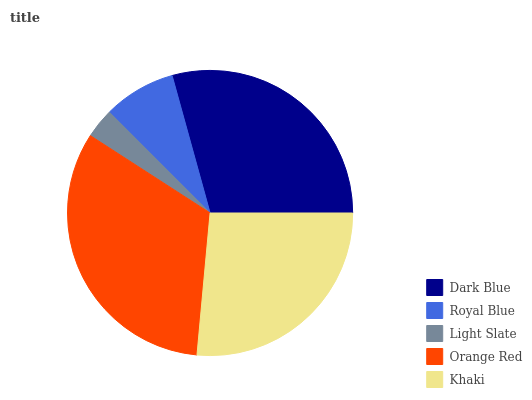Is Light Slate the minimum?
Answer yes or no. Yes. Is Orange Red the maximum?
Answer yes or no. Yes. Is Royal Blue the minimum?
Answer yes or no. No. Is Royal Blue the maximum?
Answer yes or no. No. Is Dark Blue greater than Royal Blue?
Answer yes or no. Yes. Is Royal Blue less than Dark Blue?
Answer yes or no. Yes. Is Royal Blue greater than Dark Blue?
Answer yes or no. No. Is Dark Blue less than Royal Blue?
Answer yes or no. No. Is Khaki the high median?
Answer yes or no. Yes. Is Khaki the low median?
Answer yes or no. Yes. Is Light Slate the high median?
Answer yes or no. No. Is Orange Red the low median?
Answer yes or no. No. 